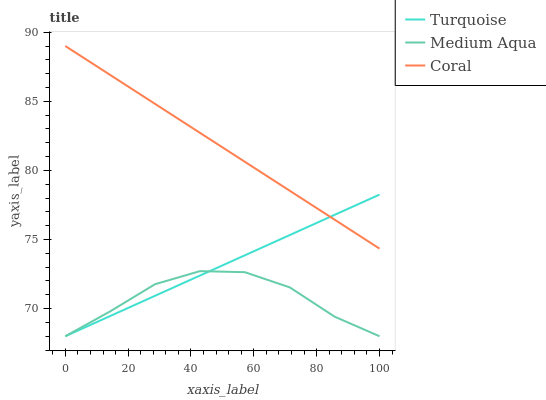Does Medium Aqua have the minimum area under the curve?
Answer yes or no. Yes. Does Coral have the maximum area under the curve?
Answer yes or no. Yes. Does Coral have the minimum area under the curve?
Answer yes or no. No. Does Medium Aqua have the maximum area under the curve?
Answer yes or no. No. Is Coral the smoothest?
Answer yes or no. Yes. Is Medium Aqua the roughest?
Answer yes or no. Yes. Is Medium Aqua the smoothest?
Answer yes or no. No. Is Coral the roughest?
Answer yes or no. No. Does Turquoise have the lowest value?
Answer yes or no. Yes. Does Coral have the lowest value?
Answer yes or no. No. Does Coral have the highest value?
Answer yes or no. Yes. Does Medium Aqua have the highest value?
Answer yes or no. No. Is Medium Aqua less than Coral?
Answer yes or no. Yes. Is Coral greater than Medium Aqua?
Answer yes or no. Yes. Does Coral intersect Turquoise?
Answer yes or no. Yes. Is Coral less than Turquoise?
Answer yes or no. No. Is Coral greater than Turquoise?
Answer yes or no. No. Does Medium Aqua intersect Coral?
Answer yes or no. No. 